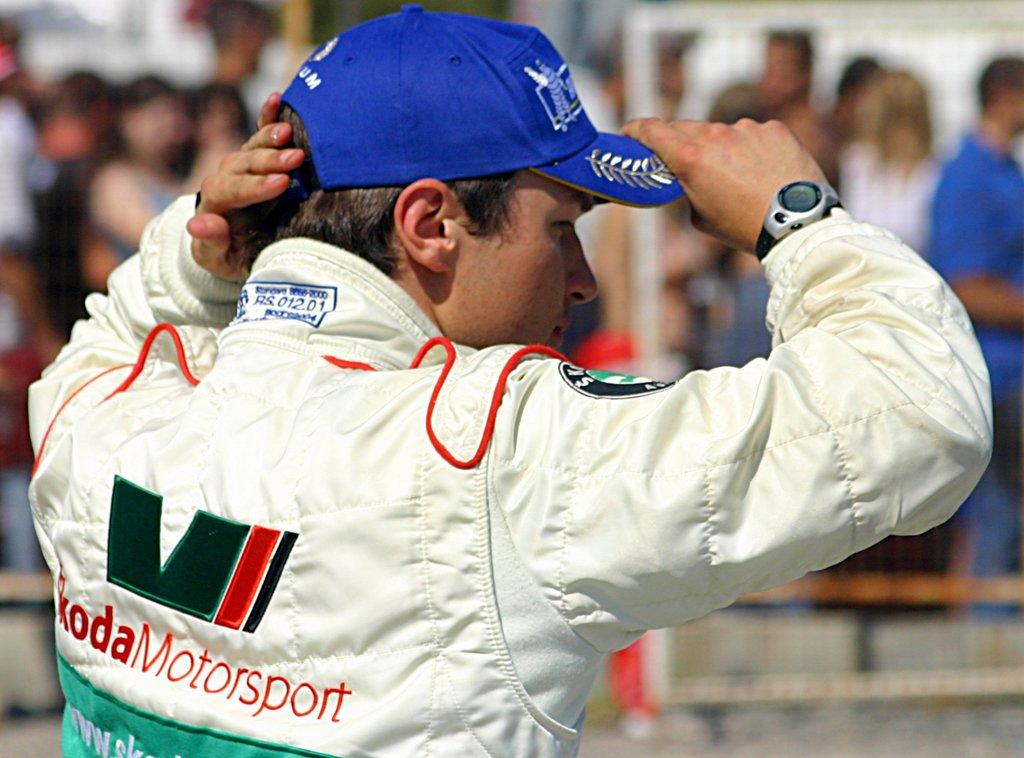Which type of event is this jacket for?
Give a very brief answer. Motorsport. Is motorsport written on the jacket?
Offer a very short reply. Yes. 